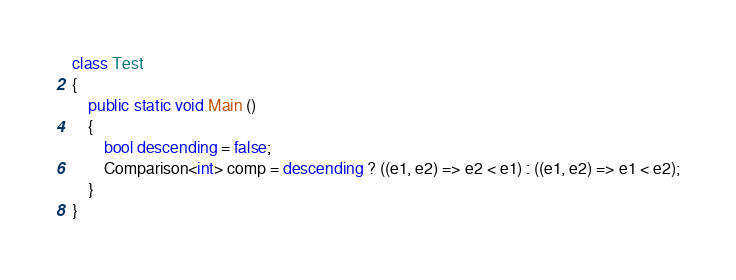<code> <loc_0><loc_0><loc_500><loc_500><_C#_>
class Test
{
	public static void Main ()
	{
		bool descending = false;
		Comparison<int> comp = descending ? ((e1, e2) => e2 < e1) : ((e1, e2) => e1 < e2);
	}
}
</code> 